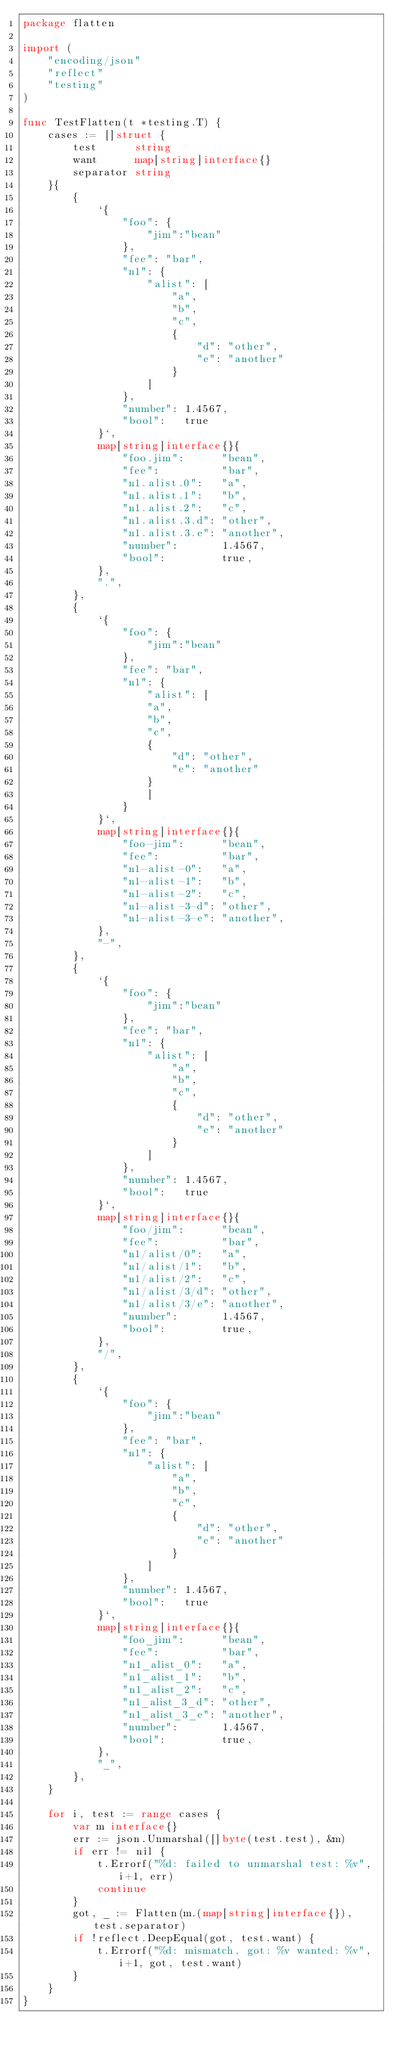Convert code to text. <code><loc_0><loc_0><loc_500><loc_500><_Go_>package flatten

import (
	"encoding/json"
	"reflect"
	"testing"
)

func TestFlatten(t *testing.T) {
	cases := []struct {
		test      string
		want      map[string]interface{}
		separator string
	}{
		{
			`{
				"foo": {
					"jim":"bean"
				},
				"fee": "bar",
				"n1": {
					"alist": [
						"a",
						"b",
						"c",
						{
							"d": "other",
							"e": "another"
						}
					]
				},
				"number": 1.4567,
				"bool":   true
			}`,
			map[string]interface{}{
				"foo.jim":      "bean",
				"fee":          "bar",
				"n1.alist.0":   "a",
				"n1.alist.1":   "b",
				"n1.alist.2":   "c",
				"n1.alist.3.d": "other",
				"n1.alist.3.e": "another",
				"number":       1.4567,
				"bool":         true,
			},
			".",
		},
		{
			`{
				"foo": {
					"jim":"bean"
				},
				"fee": "bar",
				"n1": {
					"alist": [
					"a",
					"b",
					"c",
					{
						"d": "other",
						"e": "another"
					}
					]
				}
			}`,
			map[string]interface{}{
				"foo-jim":      "bean",
				"fee":          "bar",
				"n1-alist-0":   "a",
				"n1-alist-1":   "b",
				"n1-alist-2":   "c",
				"n1-alist-3-d": "other",
				"n1-alist-3-e": "another",
			},
			"-",
		},
		{
			`{
				"foo": {
					"jim":"bean"
				},
				"fee": "bar",
				"n1": {
					"alist": [
						"a",
						"b",
						"c",
						{
							"d": "other",
							"e": "another"
						}
					]
				},
				"number": 1.4567,
				"bool":   true
			}`,
			map[string]interface{}{
				"foo/jim":      "bean",
				"fee":          "bar",
				"n1/alist/0":   "a",
				"n1/alist/1":   "b",
				"n1/alist/2":   "c",
				"n1/alist/3/d": "other",
				"n1/alist/3/e": "another",
				"number":       1.4567,
				"bool":         true,
			},
			"/",
		},
		{
			`{
				"foo": {
					"jim":"bean"
				},
				"fee": "bar",
				"n1": {
					"alist": [
						"a",
						"b",
						"c",
						{
							"d": "other",
							"e": "another"
						}
					]
				},
				"number": 1.4567,
				"bool":   true
			}`,
			map[string]interface{}{
				"foo_jim":      "bean",
				"fee":          "bar",
				"n1_alist_0":   "a",
				"n1_alist_1":   "b",
				"n1_alist_2":   "c",
				"n1_alist_3_d": "other",
				"n1_alist_3_e": "another",
				"number":       1.4567,
				"bool":         true,
			},
			"_",
		},
	}

	for i, test := range cases {
		var m interface{}
		err := json.Unmarshal([]byte(test.test), &m)
		if err != nil {
			t.Errorf("%d: failed to unmarshal test: %v", i+1, err)
			continue
		}
		got, _ := Flatten(m.(map[string]interface{}), test.separator)
		if !reflect.DeepEqual(got, test.want) {
			t.Errorf("%d: mismatch, got: %v wanted: %v", i+1, got, test.want)
		}
	}
}
</code> 